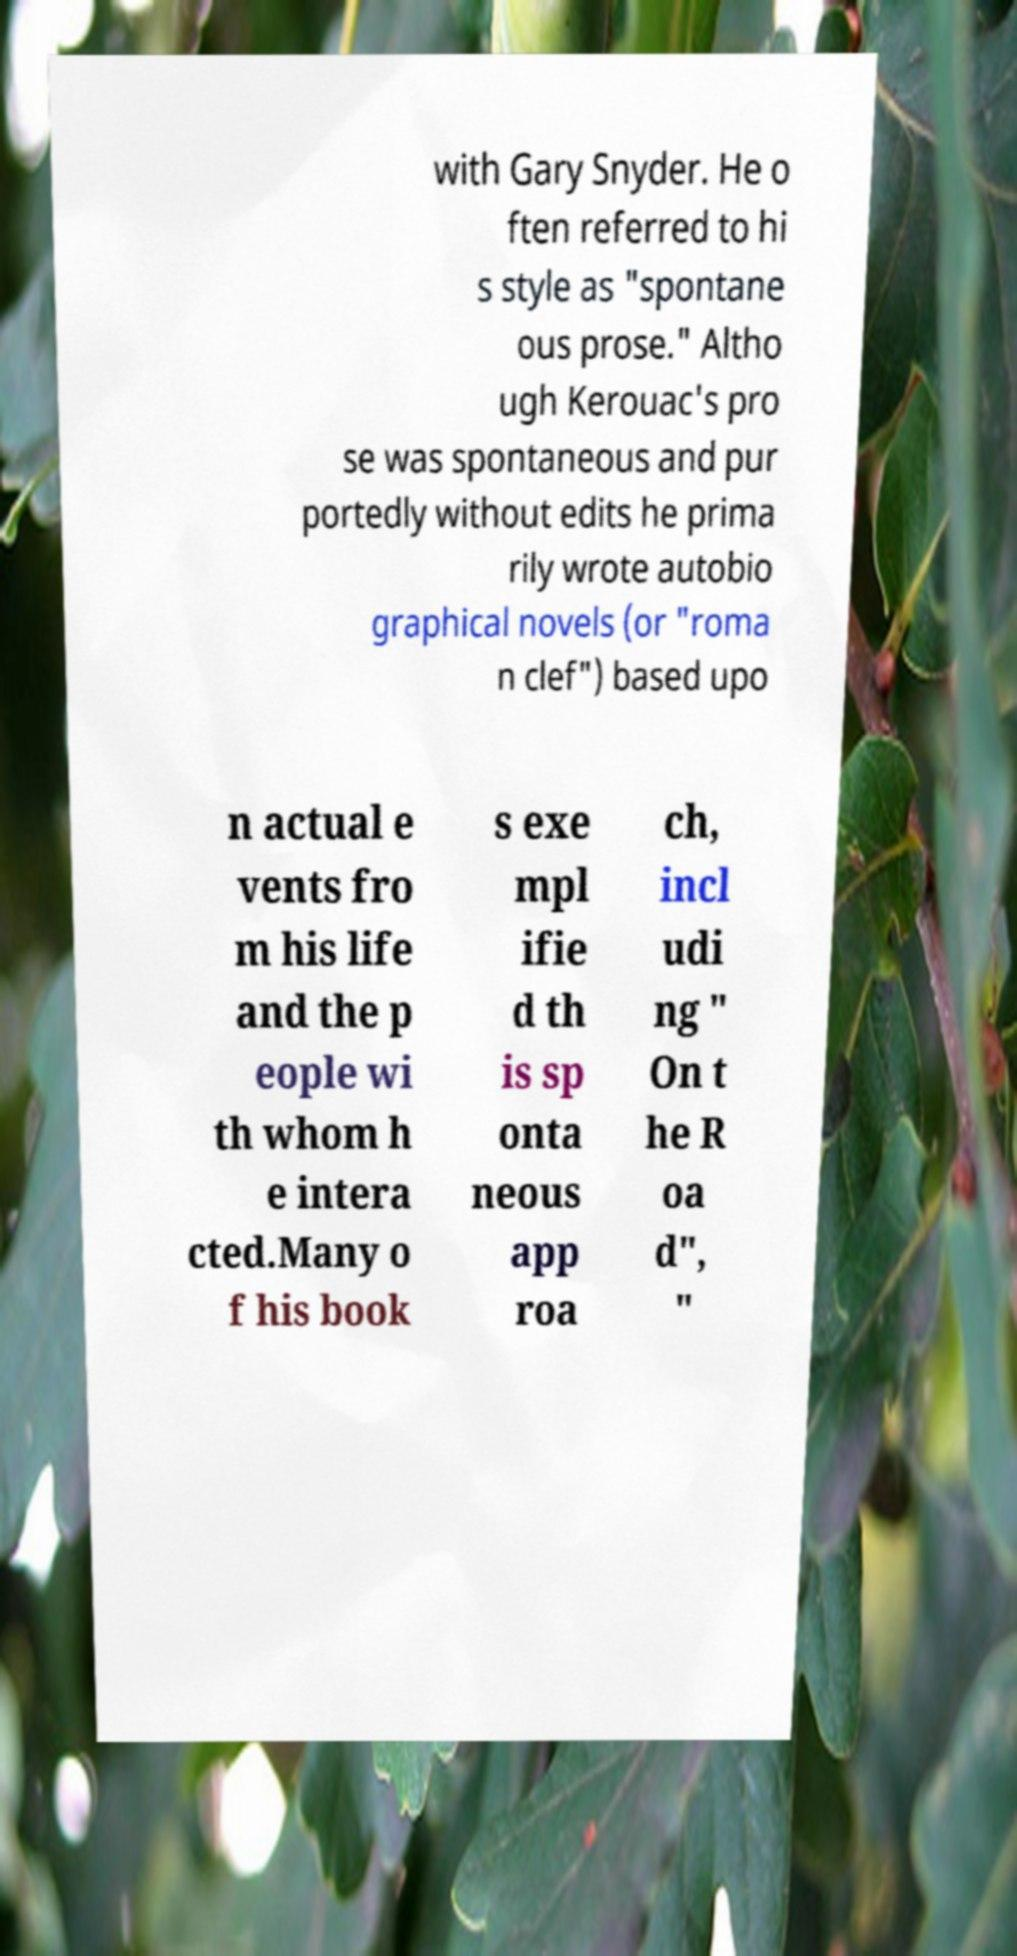Please identify and transcribe the text found in this image. with Gary Snyder. He o ften referred to hi s style as "spontane ous prose." Altho ugh Kerouac's pro se was spontaneous and pur portedly without edits he prima rily wrote autobio graphical novels (or "roma n clef") based upo n actual e vents fro m his life and the p eople wi th whom h e intera cted.Many o f his book s exe mpl ifie d th is sp onta neous app roa ch, incl udi ng " On t he R oa d", " 